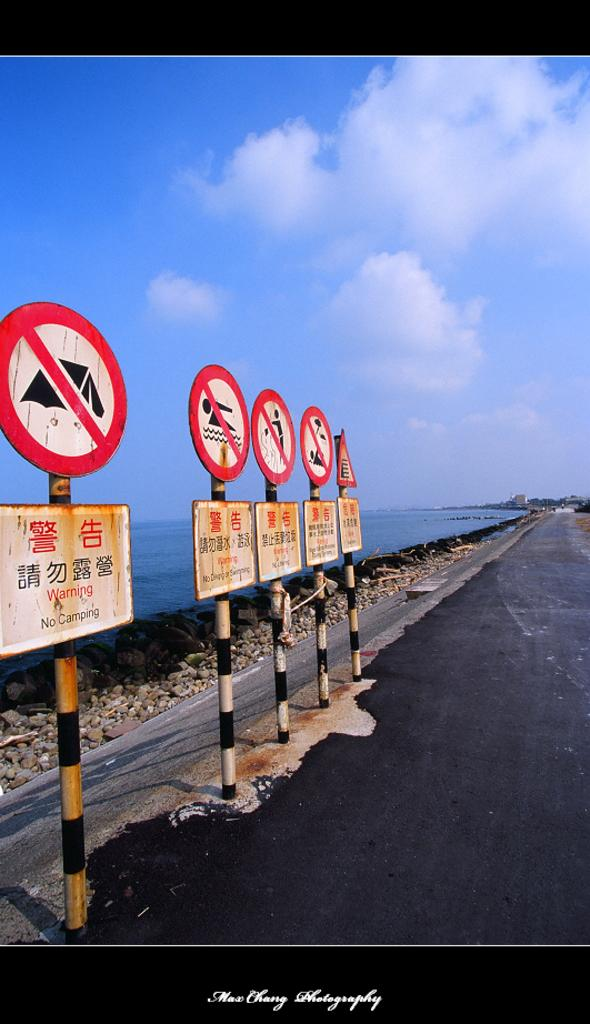Provide a one-sentence caption for the provided image. Signs on the side of a road in a foreign language. 